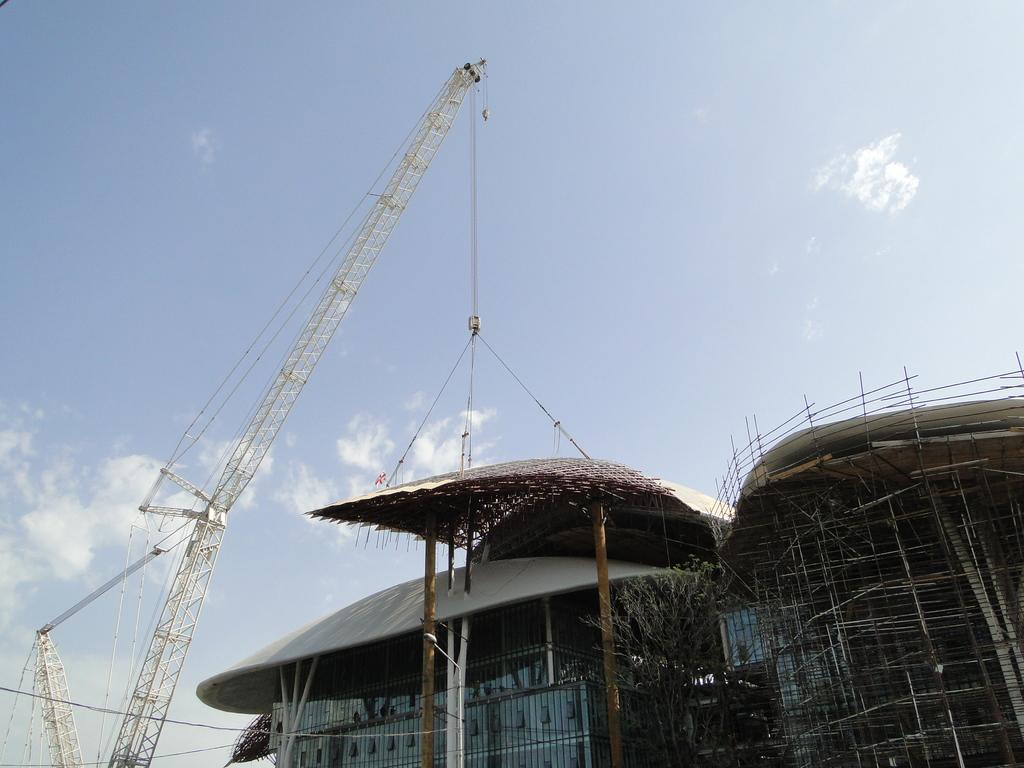What type of structure can be seen in the image? There is a building in the image. Can you describe the state of the building? There is an under-construction building in the image. What other objects can be seen in the image? There is a tree and a crane holding weight in the image. How would you describe the sky in the image? The sky is blue and cloudy in the image. How many snails can be seen crawling on the building in the image? There are no snails visible in the image; it features a building under construction, a tree, and a crane holding weight. What type of pear is hanging from the crane in the image? There is no pear present in the image; it only features a building, a tree, and a crane holding weight. 